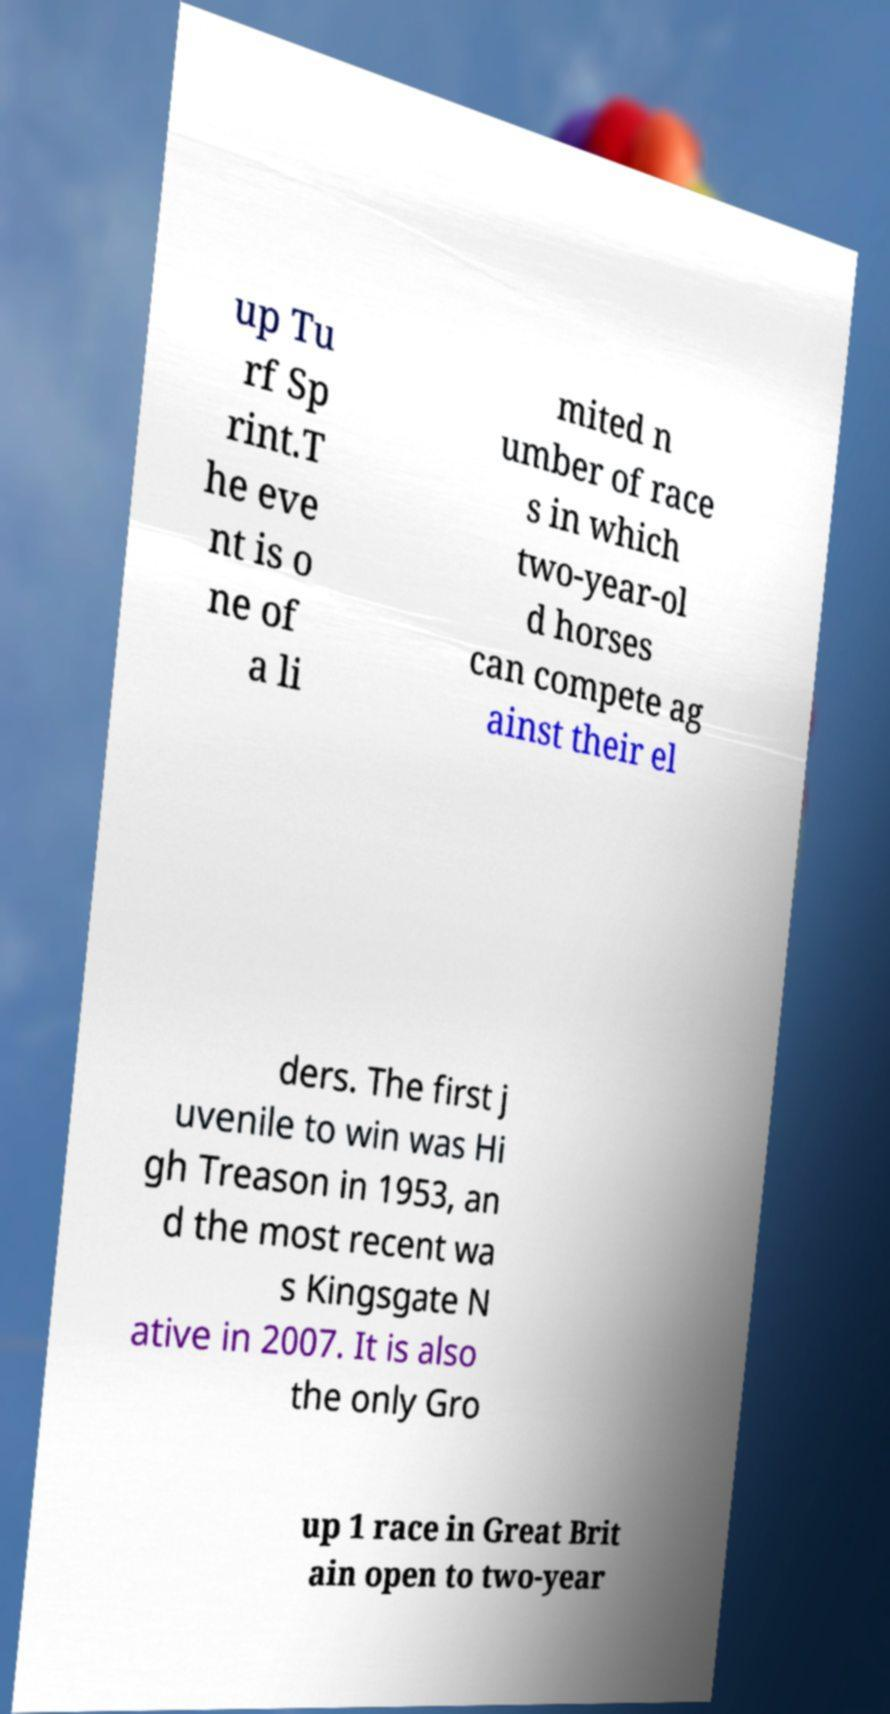Could you assist in decoding the text presented in this image and type it out clearly? up Tu rf Sp rint.T he eve nt is o ne of a li mited n umber of race s in which two-year-ol d horses can compete ag ainst their el ders. The first j uvenile to win was Hi gh Treason in 1953, an d the most recent wa s Kingsgate N ative in 2007. It is also the only Gro up 1 race in Great Brit ain open to two-year 